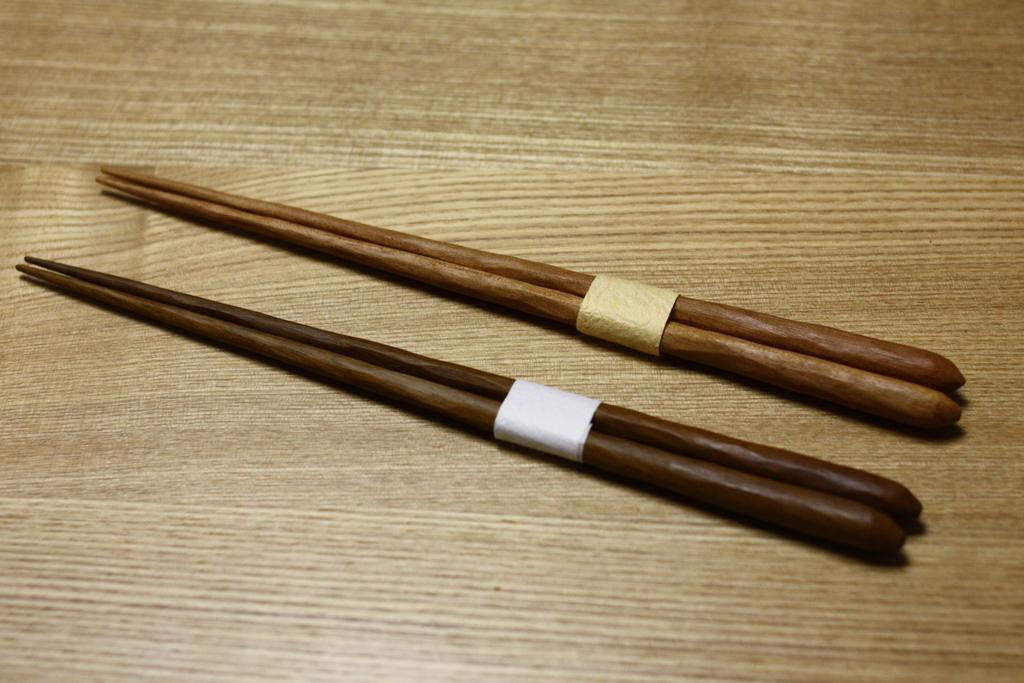How many chopsticks are visible in the image? There are two pairs of chopsticks in the image. What surface are the chopsticks placed on? The chopsticks are placed on a wooden table. What type of science experiment is being conducted with the oatmeal in the image? There is no oatmeal present in the image, and therefore no science experiment can be observed. 